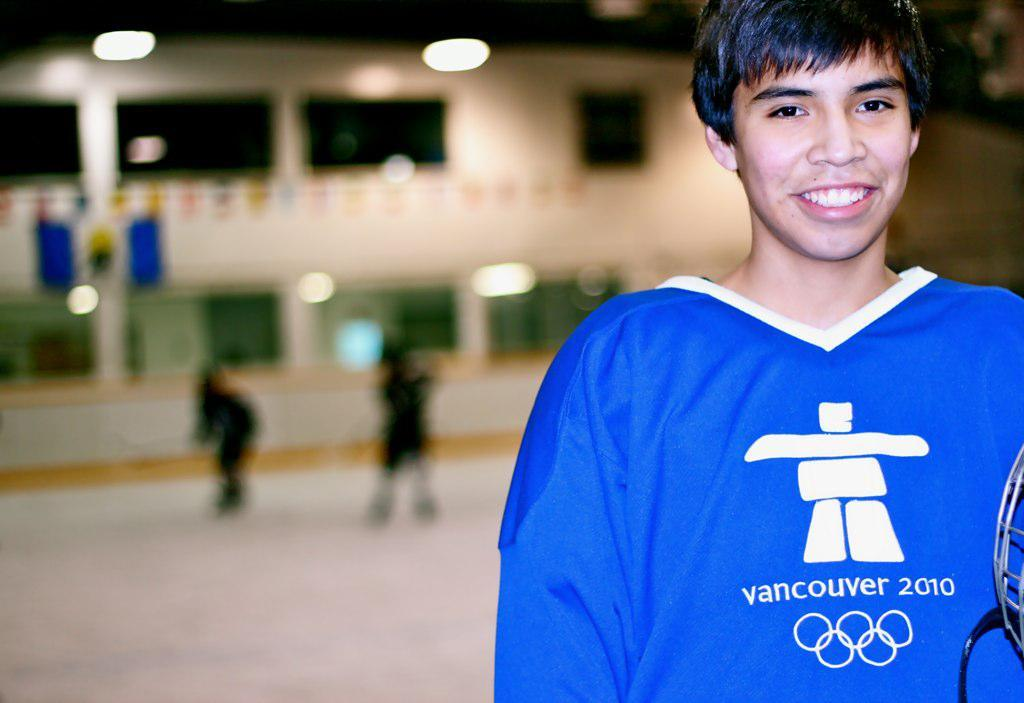What is the main subject of the image? There is a person in the image. Can you describe the person's appearance? The person is wearing clothes. What can be observed about the background of the image? The background of the image is blurred. How many cars are parked next to the person in the image? There are no cars visible in the image; it only features a person with a blurred background. Is the person in the image holding an umbrella during the rainstorm? There is no rainstorm depicted in the image, nor is there any mention of an umbrella. 